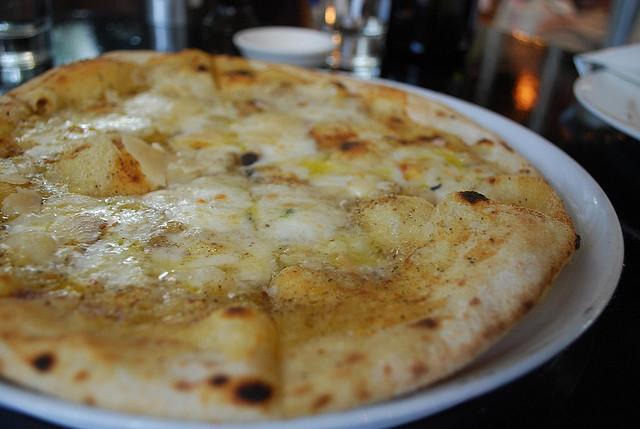How many people are working on a suntan?
Give a very brief answer. 0. 